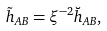Convert formula to latex. <formula><loc_0><loc_0><loc_500><loc_500>\tilde { h } _ { A B } = \xi ^ { - 2 } \breve { h } _ { A B } ,</formula> 